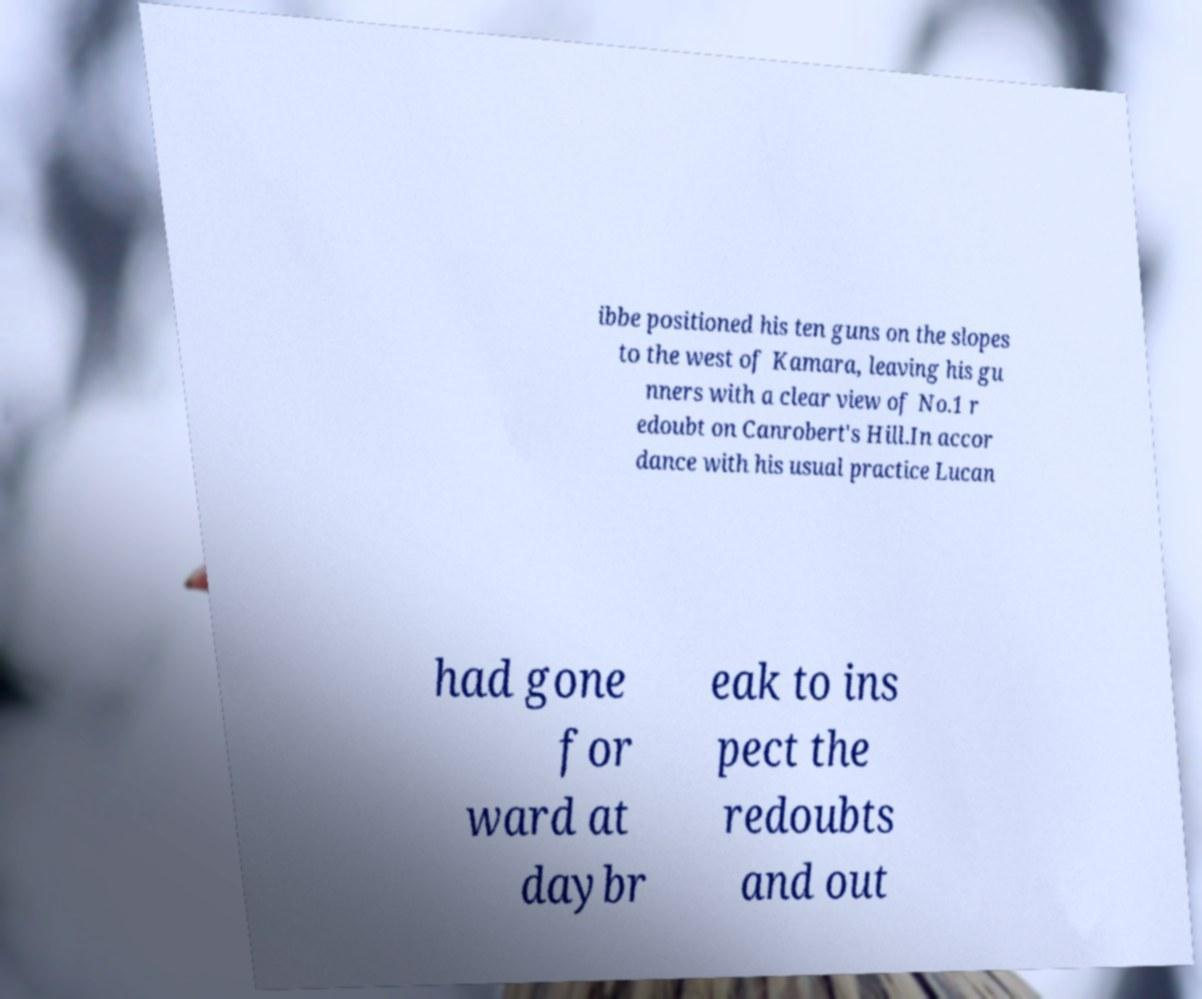Can you read and provide the text displayed in the image?This photo seems to have some interesting text. Can you extract and type it out for me? ibbe positioned his ten guns on the slopes to the west of Kamara, leaving his gu nners with a clear view of No.1 r edoubt on Canrobert's Hill.In accor dance with his usual practice Lucan had gone for ward at daybr eak to ins pect the redoubts and out 